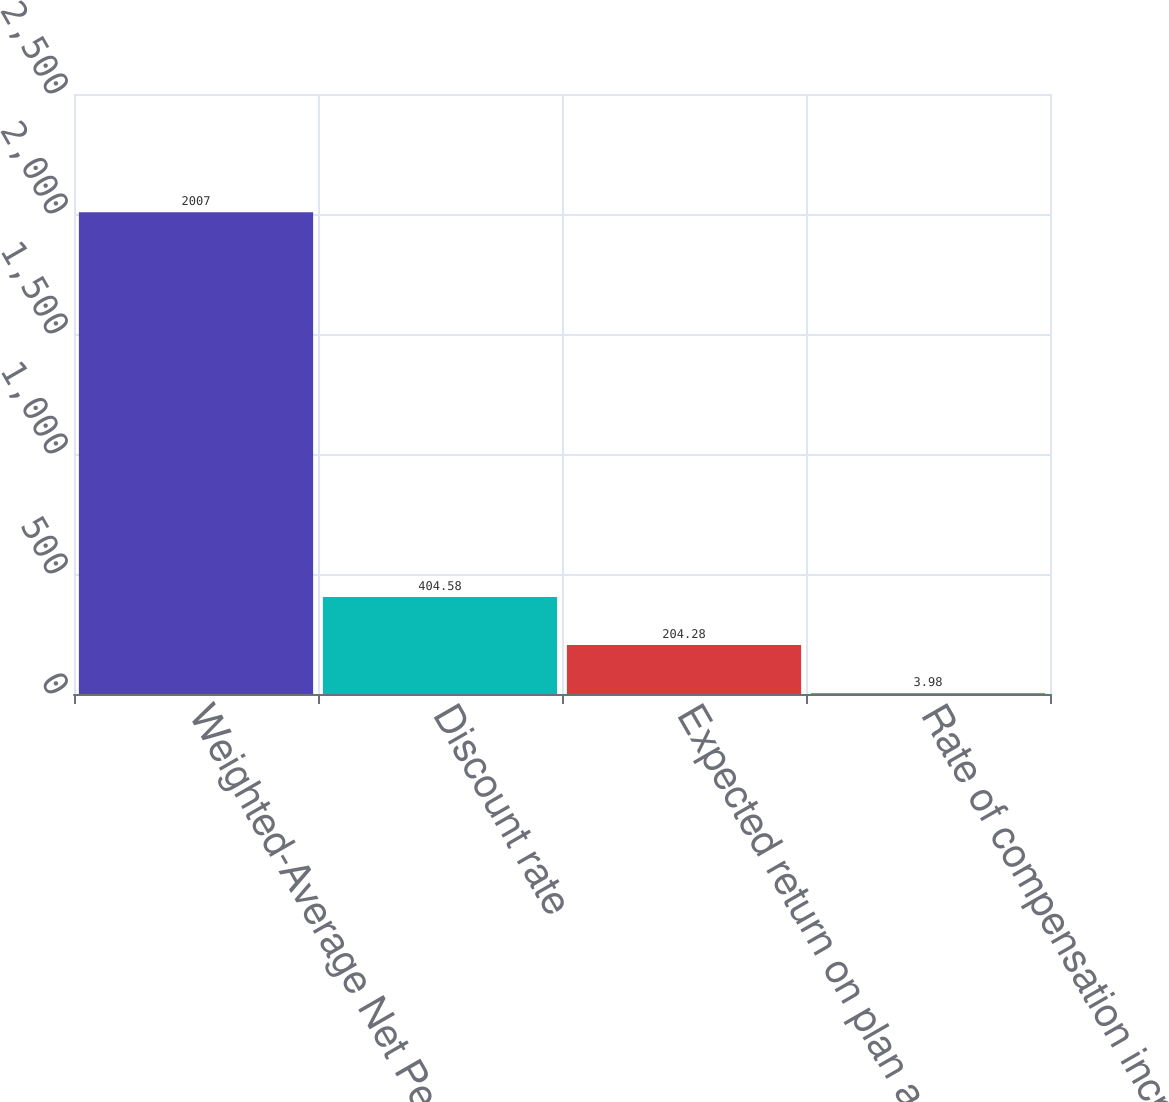<chart> <loc_0><loc_0><loc_500><loc_500><bar_chart><fcel>Weighted-Average Net Periodic<fcel>Discount rate<fcel>Expected return on plan assets<fcel>Rate of compensation increase<nl><fcel>2007<fcel>404.58<fcel>204.28<fcel>3.98<nl></chart> 